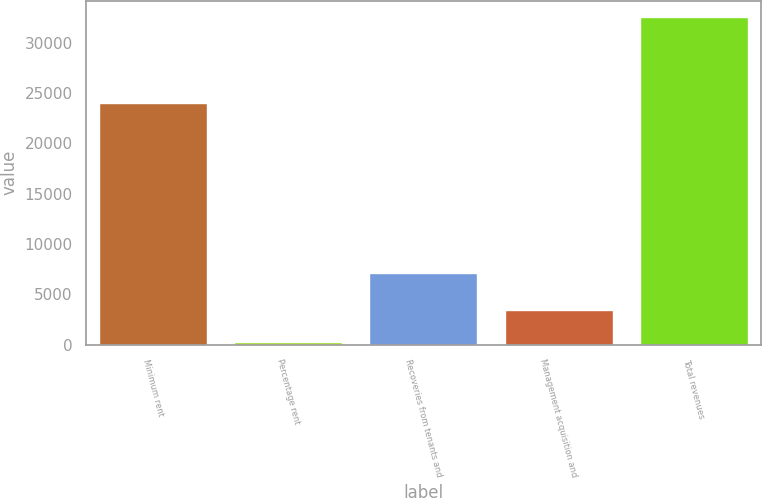<chart> <loc_0><loc_0><loc_500><loc_500><bar_chart><fcel>Minimum rent<fcel>Percentage rent<fcel>Recoveries from tenants and<fcel>Management acquisition and<fcel>Total revenues<nl><fcel>23969<fcel>231<fcel>7089<fcel>3462.7<fcel>32548<nl></chart> 